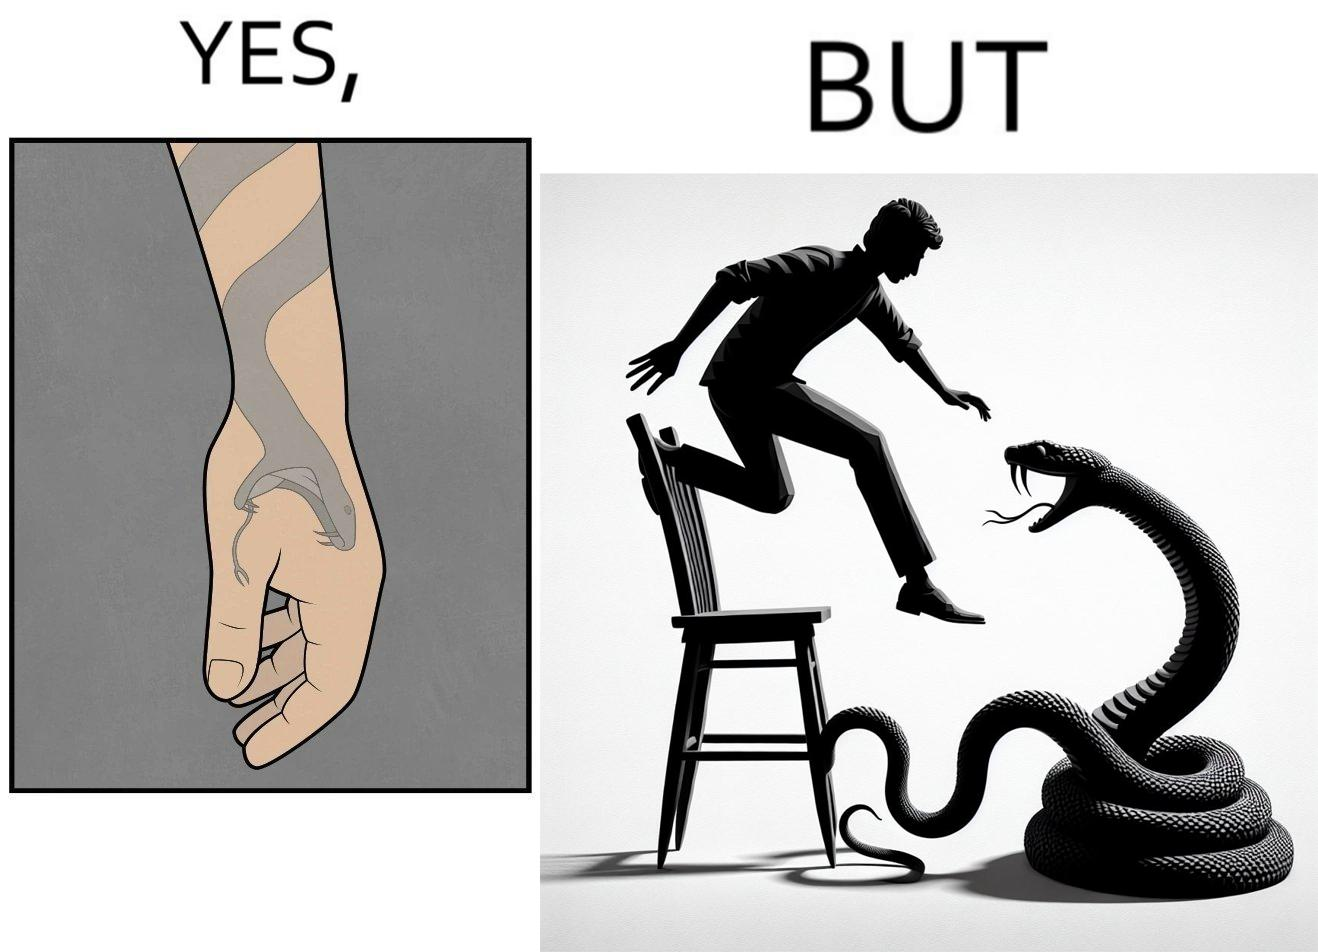Is this a satirical image? Yes, this image is satirical. 